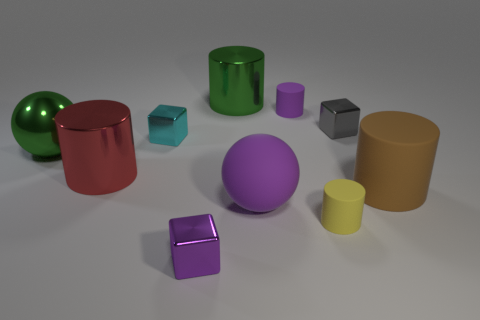Can you estimate the sizes of these objects relative to each other? Relative to one another, the objects vary in size. For instance, the large purple sphere and the brown cylinder have the most substantial volume, while the small cubes and the yellow cylinder appear to be the smallest objects in the group. 